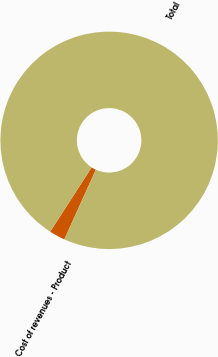<chart> <loc_0><loc_0><loc_500><loc_500><pie_chart><fcel>Cost of revenues - Product<fcel>Total<nl><fcel>2.36%<fcel>97.64%<nl></chart> 